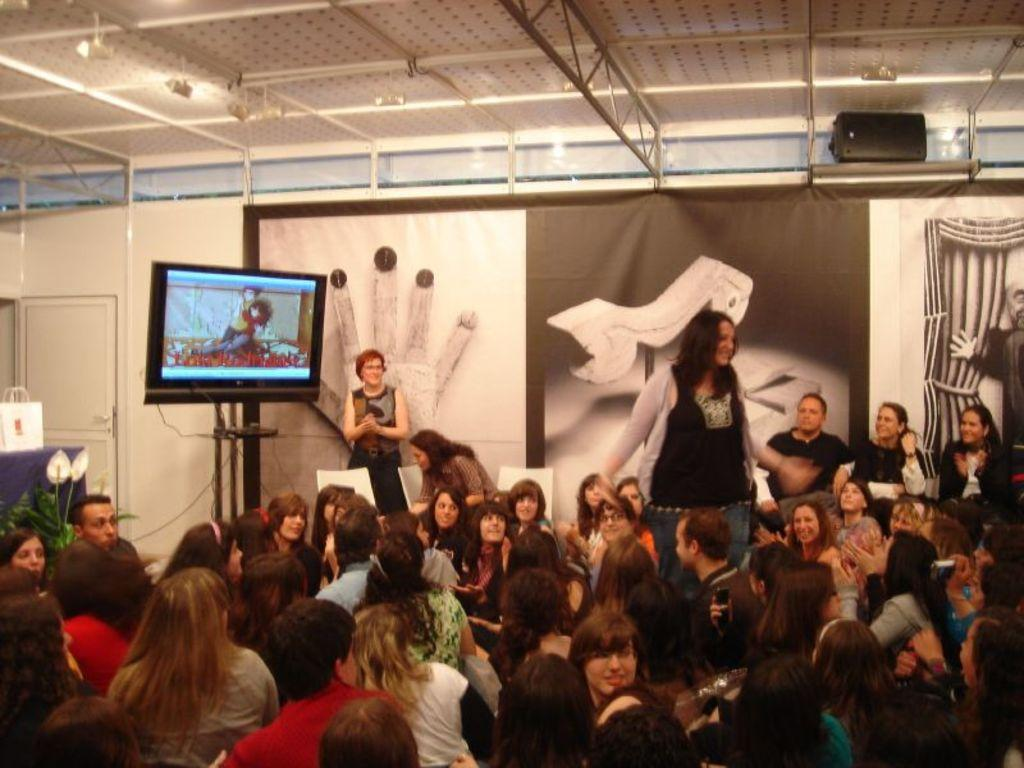What electronic device can be seen in the image? There is a television in the image. What type of structure is visible in the image? There is a wall in the image. Is there an entrance or exit in the image? Yes, there is a door in the image. What additional decoration or signage is present in the image? There is a banner in the image. Are there any people present in the image? Yes, there are people in the image. Where is the table located in the image? The table is on the left side of the image. What item can be seen on the table? There is a handbag on the table. What type of border is visible in the image? There is no mention of a border in the provided facts, so it cannot be determined from the image. What type of learning is taking place in the image? There is no indication of any learning activity in the image. 